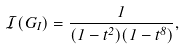Convert formula to latex. <formula><loc_0><loc_0><loc_500><loc_500>\mathcal { I } ( G _ { I } ) = \frac { 1 } { ( 1 - t ^ { 2 } ) ( 1 - t ^ { 8 } ) } ,</formula> 